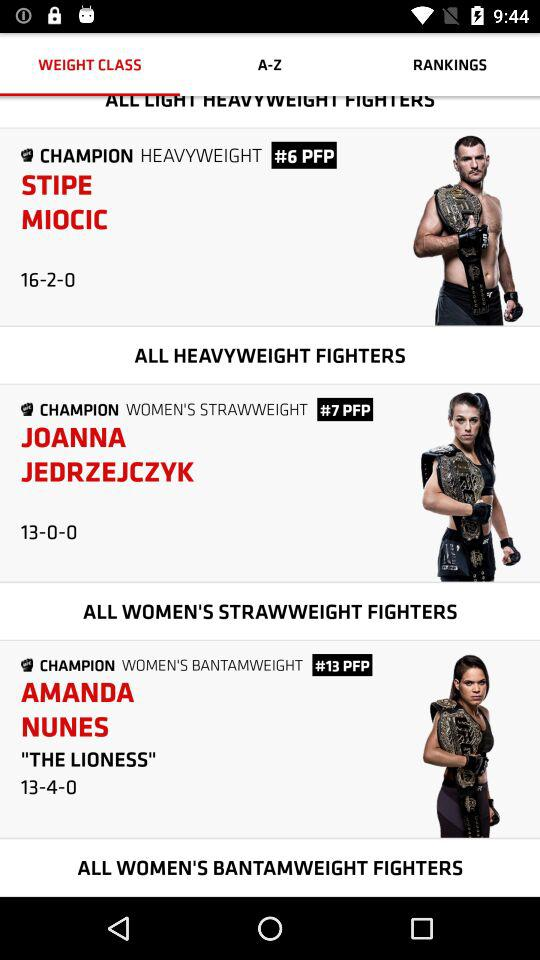Who is the champion of "WOMEN'S BANTAMWEIGHT"? The champion is Amanda Nunes. 